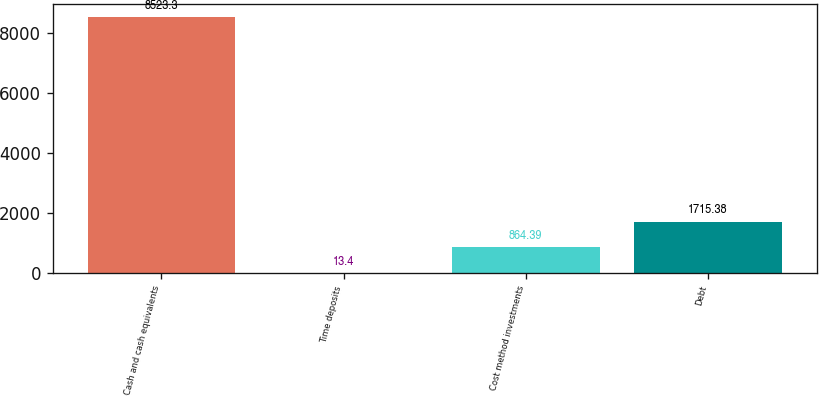Convert chart to OTSL. <chart><loc_0><loc_0><loc_500><loc_500><bar_chart><fcel>Cash and cash equivalents<fcel>Time deposits<fcel>Cost method investments<fcel>Debt<nl><fcel>8523.3<fcel>13.4<fcel>864.39<fcel>1715.38<nl></chart> 